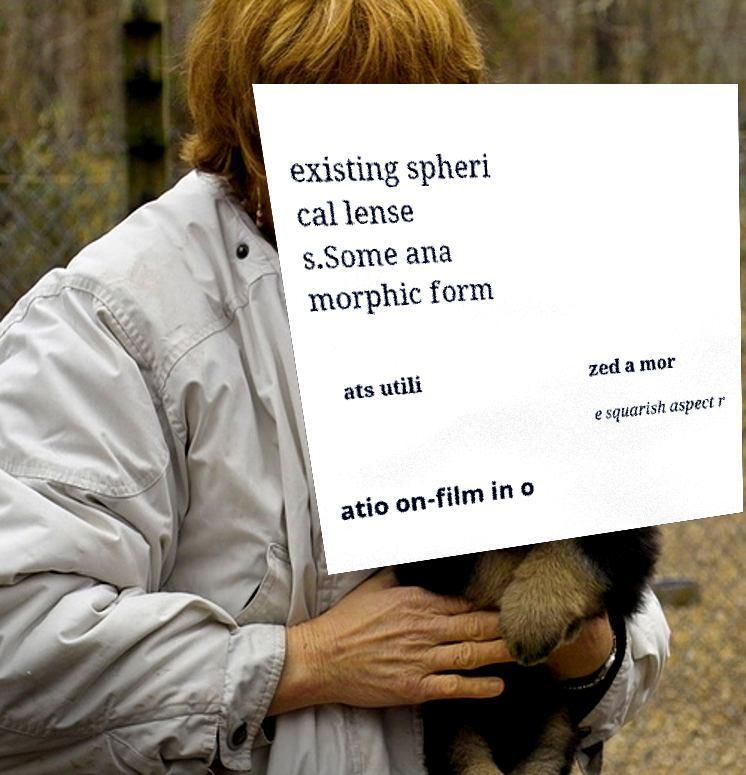Can you accurately transcribe the text from the provided image for me? existing spheri cal lense s.Some ana morphic form ats utili zed a mor e squarish aspect r atio on-film in o 